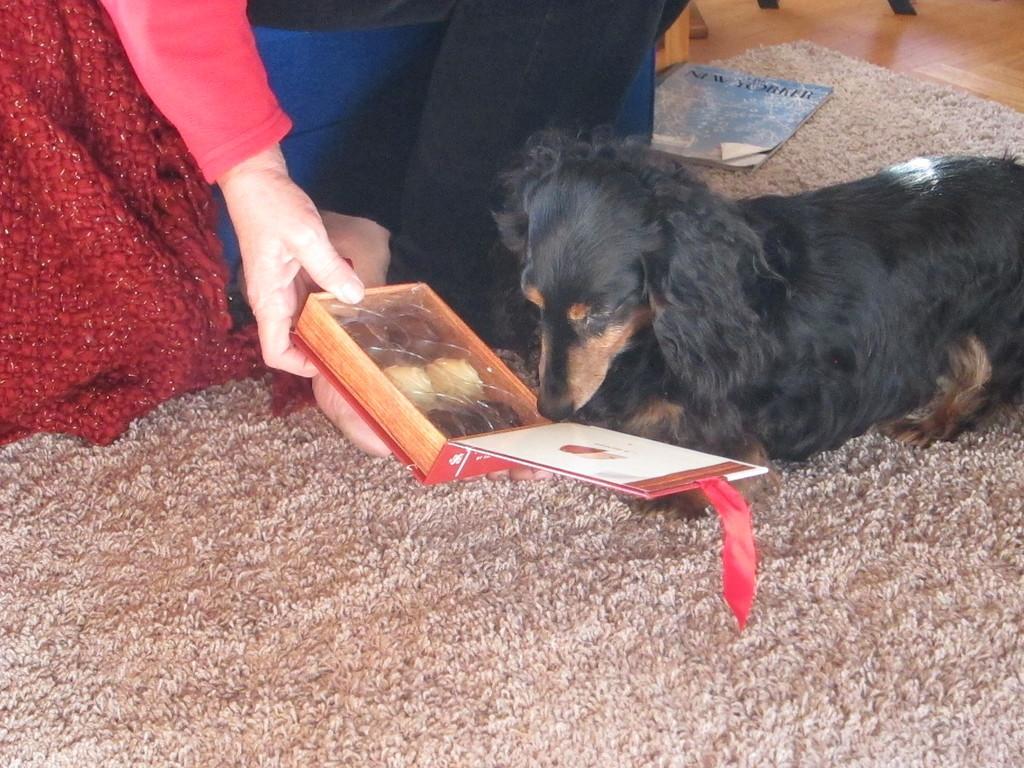Please provide a concise description of this image. In this picture there is a person holding the object and there is a dog sitting on the mat and there is a book on the mat. At the back there is an object. At the bottom there is a floor. 